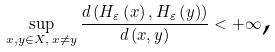Convert formula to latex. <formula><loc_0><loc_0><loc_500><loc_500>\sup _ { x , y \in X , \text { } x \neq y } \frac { d \left ( H _ { \varepsilon } \left ( x \right ) , H _ { \varepsilon } \left ( y \right ) \right ) } { d \left ( x , y \right ) } < + \infty \text {,}</formula> 